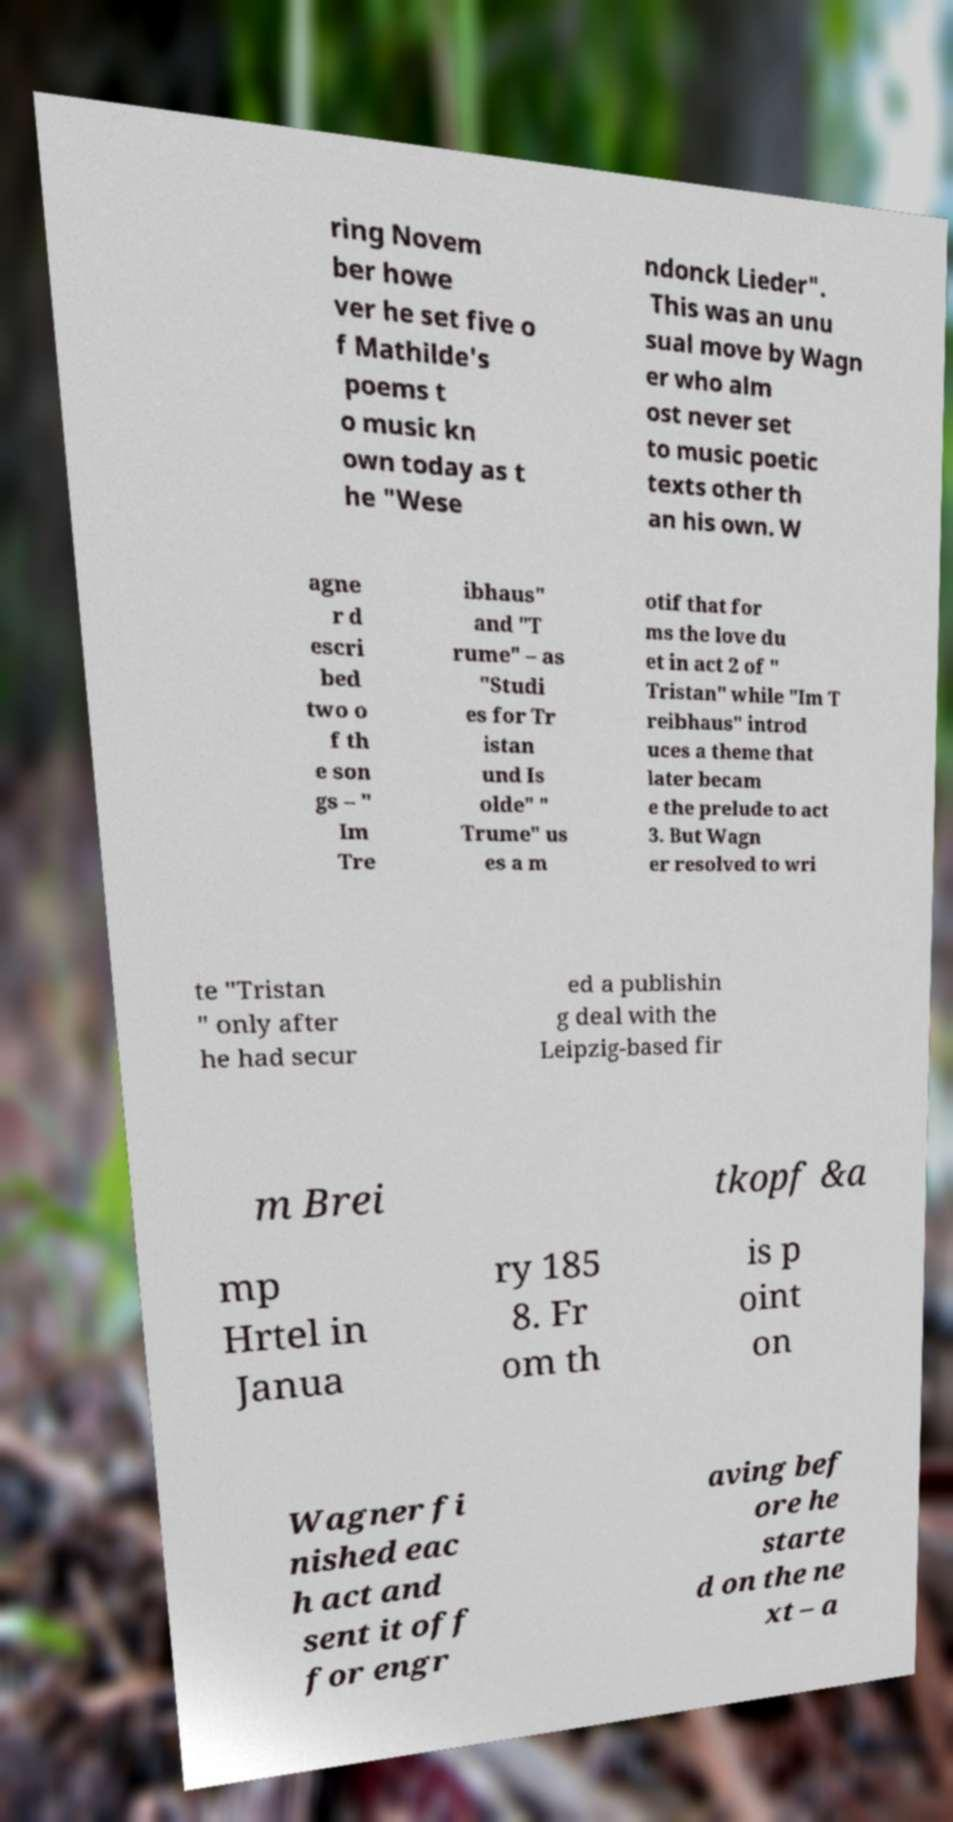Can you accurately transcribe the text from the provided image for me? ring Novem ber howe ver he set five o f Mathilde's poems t o music kn own today as t he "Wese ndonck Lieder". This was an unu sual move by Wagn er who alm ost never set to music poetic texts other th an his own. W agne r d escri bed two o f th e son gs – " Im Tre ibhaus" and "T rume" – as "Studi es for Tr istan und Is olde" " Trume" us es a m otif that for ms the love du et in act 2 of " Tristan" while "Im T reibhaus" introd uces a theme that later becam e the prelude to act 3. But Wagn er resolved to wri te "Tristan " only after he had secur ed a publishin g deal with the Leipzig-based fir m Brei tkopf &a mp Hrtel in Janua ry 185 8. Fr om th is p oint on Wagner fi nished eac h act and sent it off for engr aving bef ore he starte d on the ne xt – a 